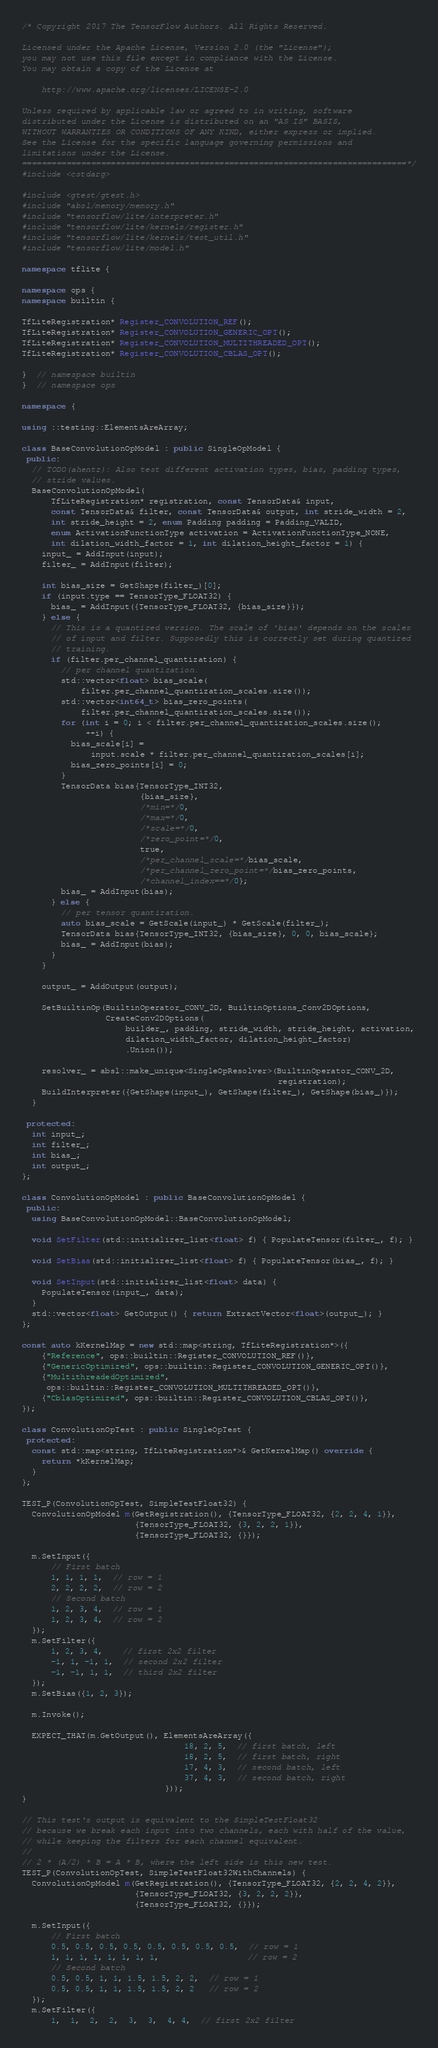<code> <loc_0><loc_0><loc_500><loc_500><_C++_>/* Copyright 2017 The TensorFlow Authors. All Rights Reserved.

Licensed under the Apache License, Version 2.0 (the "License");
you may not use this file except in compliance with the License.
You may obtain a copy of the License at

    http://www.apache.org/licenses/LICENSE-2.0

Unless required by applicable law or agreed to in writing, software
distributed under the License is distributed on an "AS IS" BASIS,
WITHOUT WARRANTIES OR CONDITIONS OF ANY KIND, either express or implied.
See the License for the specific language governing permissions and
limitations under the License.
==============================================================================*/
#include <cstdarg>

#include <gtest/gtest.h>
#include "absl/memory/memory.h"
#include "tensorflow/lite/interpreter.h"
#include "tensorflow/lite/kernels/register.h"
#include "tensorflow/lite/kernels/test_util.h"
#include "tensorflow/lite/model.h"

namespace tflite {

namespace ops {
namespace builtin {

TfLiteRegistration* Register_CONVOLUTION_REF();
TfLiteRegistration* Register_CONVOLUTION_GENERIC_OPT();
TfLiteRegistration* Register_CONVOLUTION_MULTITHREADED_OPT();
TfLiteRegistration* Register_CONVOLUTION_CBLAS_OPT();

}  // namespace builtin
}  // namespace ops

namespace {

using ::testing::ElementsAreArray;

class BaseConvolutionOpModel : public SingleOpModel {
 public:
  // TODO(ahentz): Also test different activation types, bias, padding types,
  // stride values.
  BaseConvolutionOpModel(
      TfLiteRegistration* registration, const TensorData& input,
      const TensorData& filter, const TensorData& output, int stride_width = 2,
      int stride_height = 2, enum Padding padding = Padding_VALID,
      enum ActivationFunctionType activation = ActivationFunctionType_NONE,
      int dilation_width_factor = 1, int dilation_height_factor = 1) {
    input_ = AddInput(input);
    filter_ = AddInput(filter);

    int bias_size = GetShape(filter_)[0];
    if (input.type == TensorType_FLOAT32) {
      bias_ = AddInput({TensorType_FLOAT32, {bias_size}});
    } else {
      // This is a quantized version. The scale of 'bias' depends on the scales
      // of input and filter. Supposedly this is correctly set during quantized
      // training.
      if (filter.per_channel_quantization) {
        // per channel quantization.
        std::vector<float> bias_scale(
            filter.per_channel_quantization_scales.size());
        std::vector<int64_t> bias_zero_points(
            filter.per_channel_quantization_scales.size());
        for (int i = 0; i < filter.per_channel_quantization_scales.size();
             ++i) {
          bias_scale[i] =
              input.scale * filter.per_channel_quantization_scales[i];
          bias_zero_points[i] = 0;
        }
        TensorData bias{TensorType_INT32,
                        {bias_size},
                        /*min=*/0,
                        /*max=*/0,
                        /*scale=*/0,
                        /*zero_point=*/0,
                        true,
                        /*per_channel_scale=*/bias_scale,
                        /*per_channel_zero_point=*/bias_zero_points,
                        /*channel_index==*/0};
        bias_ = AddInput(bias);
      } else {
        // per tensor quantization.
        auto bias_scale = GetScale(input_) * GetScale(filter_);
        TensorData bias{TensorType_INT32, {bias_size}, 0, 0, bias_scale};
        bias_ = AddInput(bias);
      }
    }

    output_ = AddOutput(output);

    SetBuiltinOp(BuiltinOperator_CONV_2D, BuiltinOptions_Conv2DOptions,
                 CreateConv2DOptions(
                     builder_, padding, stride_width, stride_height, activation,
                     dilation_width_factor, dilation_height_factor)
                     .Union());

    resolver_ = absl::make_unique<SingleOpResolver>(BuiltinOperator_CONV_2D,
                                                    registration);
    BuildInterpreter({GetShape(input_), GetShape(filter_), GetShape(bias_)});
  }

 protected:
  int input_;
  int filter_;
  int bias_;
  int output_;
};

class ConvolutionOpModel : public BaseConvolutionOpModel {
 public:
  using BaseConvolutionOpModel::BaseConvolutionOpModel;

  void SetFilter(std::initializer_list<float> f) { PopulateTensor(filter_, f); }

  void SetBias(std::initializer_list<float> f) { PopulateTensor(bias_, f); }

  void SetInput(std::initializer_list<float> data) {
    PopulateTensor(input_, data);
  }
  std::vector<float> GetOutput() { return ExtractVector<float>(output_); }
};

const auto kKernelMap = new std::map<string, TfLiteRegistration*>({
    {"Reference", ops::builtin::Register_CONVOLUTION_REF()},
    {"GenericOptimized", ops::builtin::Register_CONVOLUTION_GENERIC_OPT()},
    {"MultithreadedOptimized",
     ops::builtin::Register_CONVOLUTION_MULTITHREADED_OPT()},
    {"CblasOptimized", ops::builtin::Register_CONVOLUTION_CBLAS_OPT()},
});

class ConvolutionOpTest : public SingleOpTest {
 protected:
  const std::map<string, TfLiteRegistration*>& GetKernelMap() override {
    return *kKernelMap;
  }
};

TEST_P(ConvolutionOpTest, SimpleTestFloat32) {
  ConvolutionOpModel m(GetRegistration(), {TensorType_FLOAT32, {2, 2, 4, 1}},
                       {TensorType_FLOAT32, {3, 2, 2, 1}},
                       {TensorType_FLOAT32, {}});

  m.SetInput({
      // First batch
      1, 1, 1, 1,  // row = 1
      2, 2, 2, 2,  // row = 2
      // Second batch
      1, 2, 3, 4,  // row = 1
      1, 2, 3, 4,  // row = 2
  });
  m.SetFilter({
      1, 2, 3, 4,    // first 2x2 filter
      -1, 1, -1, 1,  // second 2x2 filter
      -1, -1, 1, 1,  // third 2x2 filter
  });
  m.SetBias({1, 2, 3});

  m.Invoke();

  EXPECT_THAT(m.GetOutput(), ElementsAreArray({
                                 18, 2, 5,  // first batch, left
                                 18, 2, 5,  // first batch, right
                                 17, 4, 3,  // second batch, left
                                 37, 4, 3,  // second batch, right
                             }));
}

// This test's output is equivalent to the SimpleTestFloat32
// because we break each input into two channels, each with half of the value,
// while keeping the filters for each channel equivalent.
//
// 2 * (A/2) * B = A * B, where the left side is this new test.
TEST_P(ConvolutionOpTest, SimpleTestFloat32WithChannels) {
  ConvolutionOpModel m(GetRegistration(), {TensorType_FLOAT32, {2, 2, 4, 2}},
                       {TensorType_FLOAT32, {3, 2, 2, 2}},
                       {TensorType_FLOAT32, {}});

  m.SetInput({
      // First batch
      0.5, 0.5, 0.5, 0.5, 0.5, 0.5, 0.5, 0.5,  // row = 1
      1, 1, 1, 1, 1, 1, 1, 1,                  // row = 2
      // Second batch
      0.5, 0.5, 1, 1, 1.5, 1.5, 2, 2,  // row = 1
      0.5, 0.5, 1, 1, 1.5, 1.5, 2, 2   // row = 2
  });
  m.SetFilter({
      1,  1,  2,  2,  3,  3,  4, 4,  // first 2x2 filter</code> 